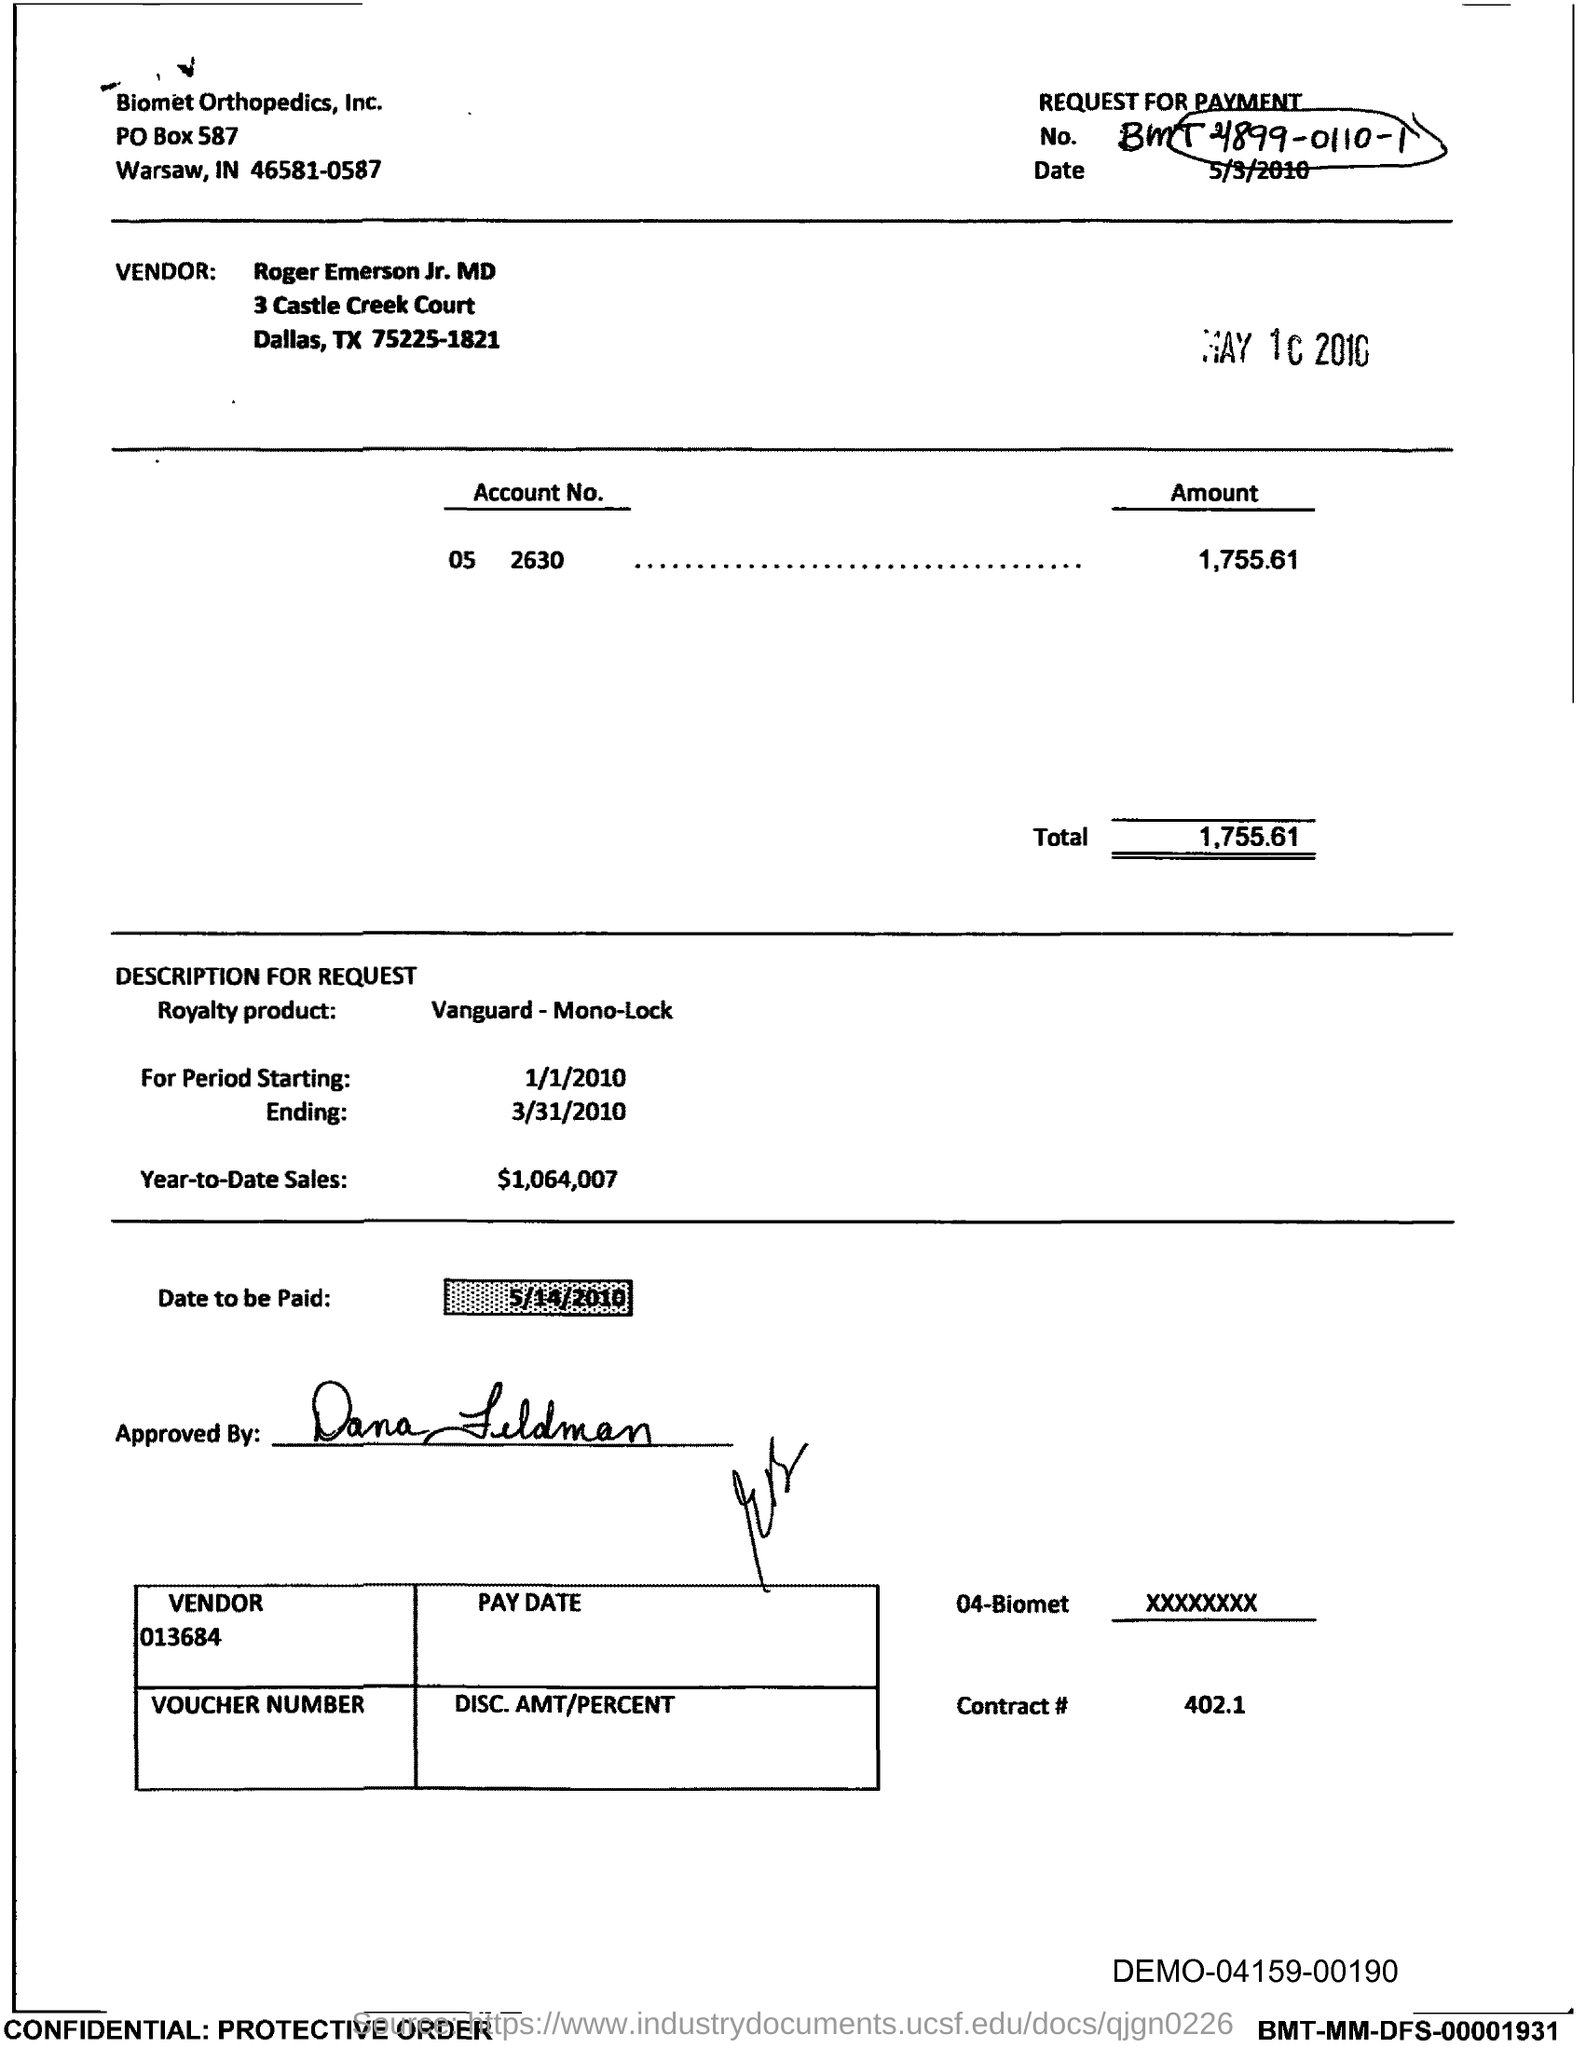What is the PO Box Number mentioned in the document?
Provide a short and direct response. 587. What is the Contract # Number?
Ensure brevity in your answer.  402.1. What is the Total?
Offer a terse response. 1,755.61. 